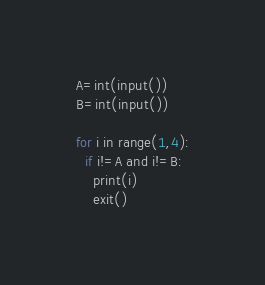<code> <loc_0><loc_0><loc_500><loc_500><_Python_>A=int(input())
B=int(input())

for i in range(1,4):
  if i!=A and i!=B:
    print(i)
    exit()</code> 